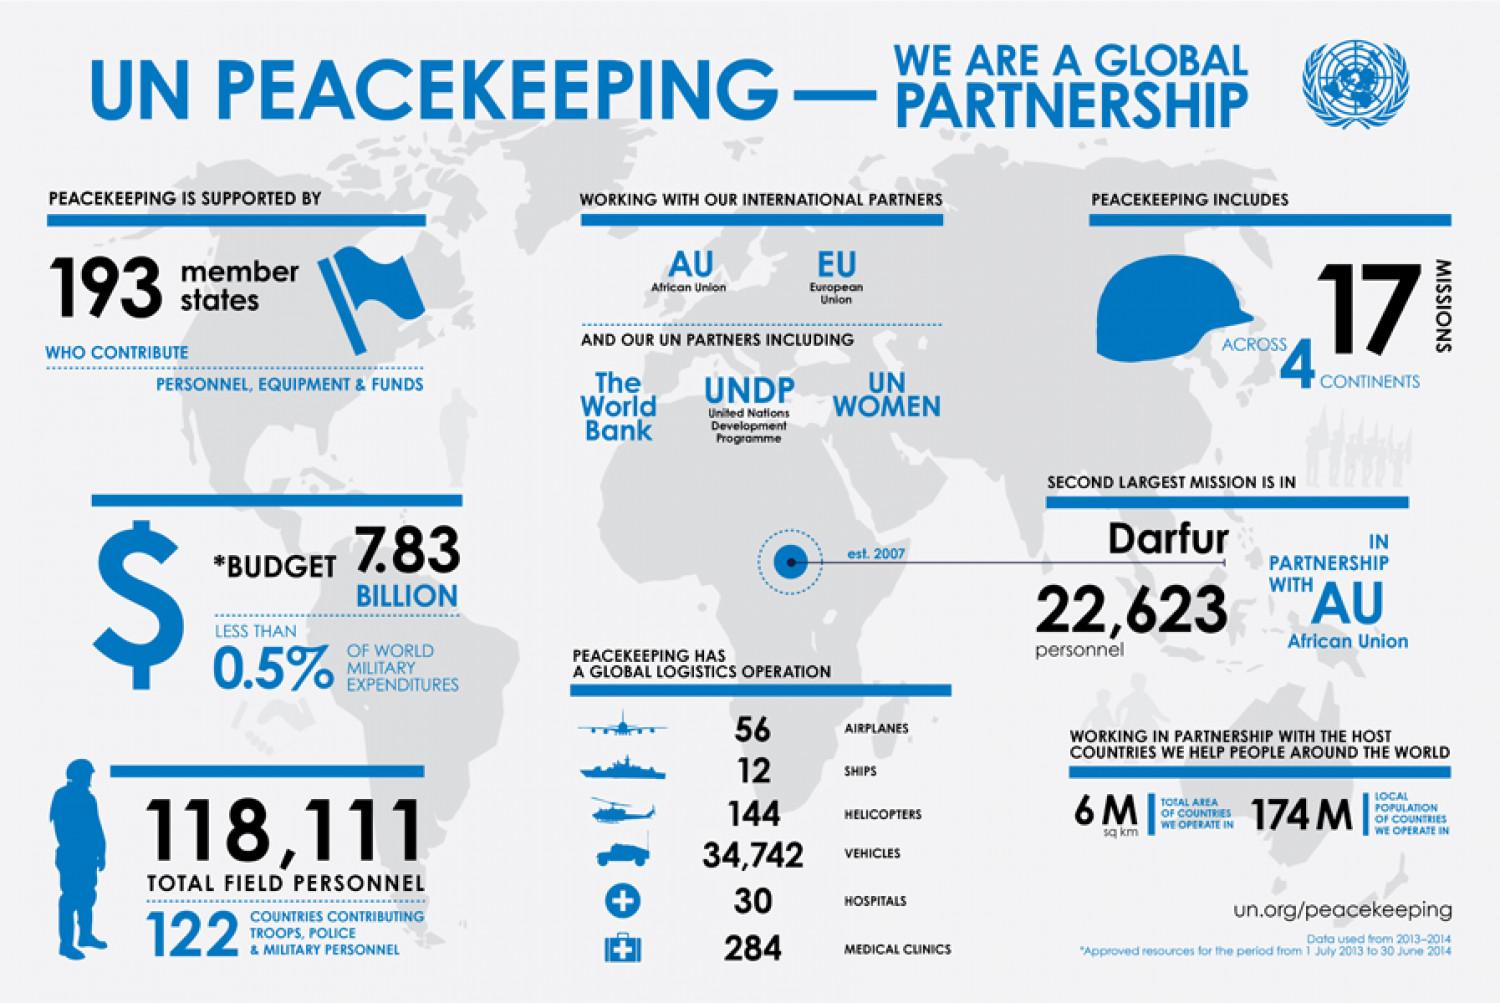Highlight a few significant elements in this photo. A total of 193 member states have contributed to UN peacekeeping operations. The total budget for UN peacekeeping operations is 7.83 BILLION dollars. In 2007, the United Nations deployed 22,623 personnel in its Darfur mission. The second largest UN peacekeeping mission operates in the Darfur region. A total of 17 missions have been carried out by the United Nations peacekeepers across different continents. 